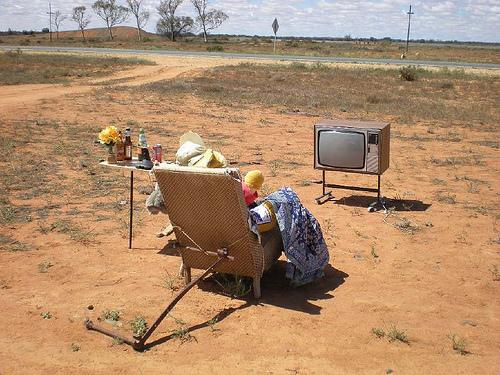What's connected to the back of the chair? metal 